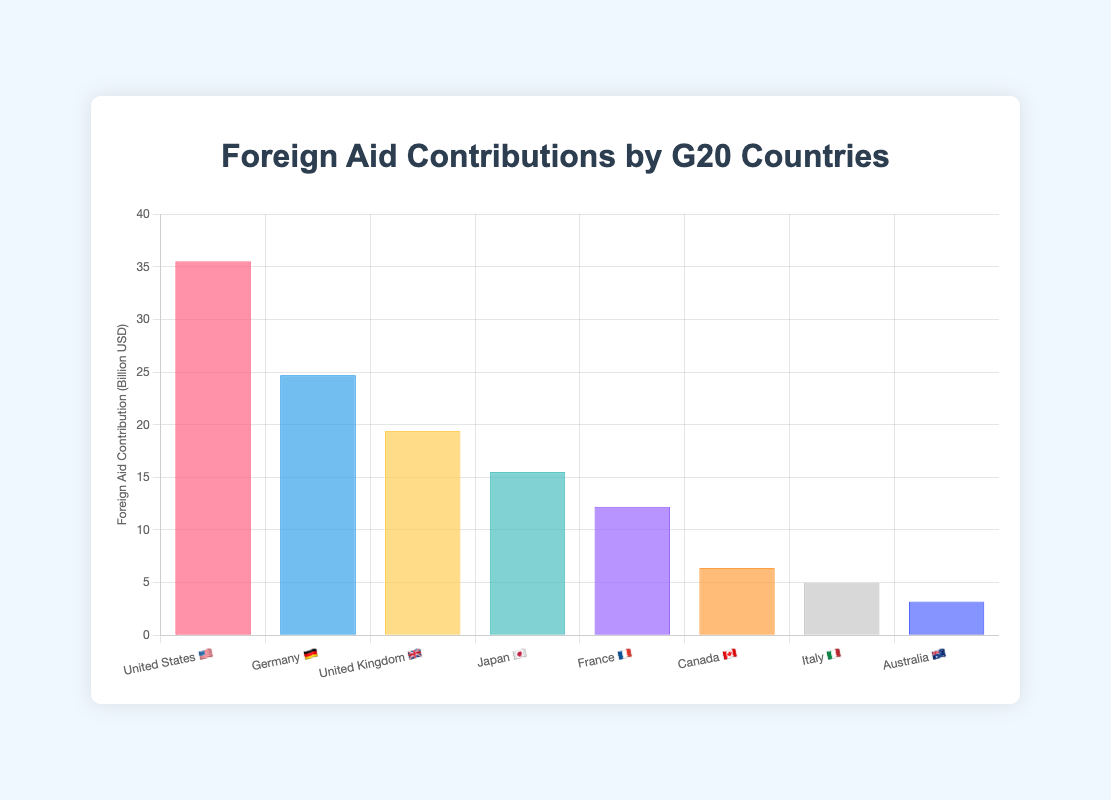Which country contributes the most foreign aid? The figure shows the countries and their contributions. The United States has the highest value.
Answer: United States 🇺🇸 Which country contributes the least foreign aid? The figure shows the countries and their contributions. Australia has the lowest value.
Answer: Australia 🇦🇺 How much foreign aid does Japan contribute? Look for Japan in the figure to see its contribution. Japan contributes 15.5 billion USD.
Answer: 15.5 billion USD What is the total foreign aid contributed by Germany and the United Kingdom? Sum the values for Germany (24.7 billion USD) and the United Kingdom (19.4 billion USD). 24.7 + 19.4 = 44.1
Answer: 44.1 billion USD Which country uses the Euro (€) for its foreign aid contributions and also contributes more than 20 billion USD? Identify countries using the Euro. Germany and France use the Euro, but only Germany contributes more than 20 billion USD.
Answer: Germany 🇩🇪 How many countries contribute more than 10 billion USD? Count the number of countries whose contributions are above 10 billion USD. The countries are the United States, Germany, United Kingdom, Japan, and France (5 countries).
Answer: 5 Is there any country whose contribution is exactly 5 billion USD? Locate a country that has exactly 5 billion USD in the figure. Italy contributes exactly 5 billion USD.
Answer: Italy 🇮🇹 What is the combined foreign aid contribution of countries that use USD (💵)? Add the contributions of the United States (35.5), Canada (6.4), and Australia (3.2). 35.5 + 6.4 + 3.2 = 45.1 billion USD
Answer: 45.1 billion USD 